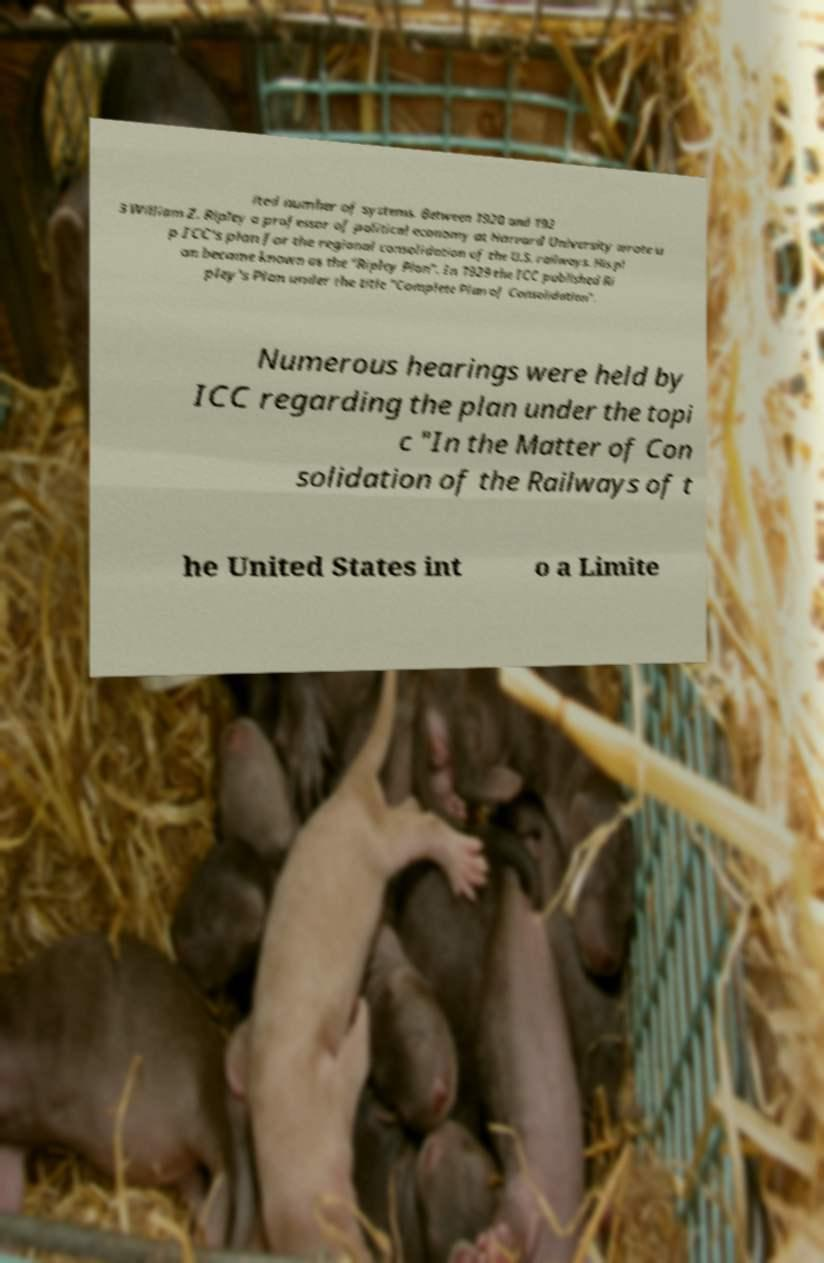Please identify and transcribe the text found in this image. ited number of systems. Between 1920 and 192 3 William Z. Ripley a professor of political economy at Harvard University wrote u p ICC's plan for the regional consolidation of the U.S. railways. His pl an became known as the "Ripley Plan". In 1929 the ICC published Ri pley's Plan under the title "Complete Plan of Consolidation". Numerous hearings were held by ICC regarding the plan under the topi c "In the Matter of Con solidation of the Railways of t he United States int o a Limite 